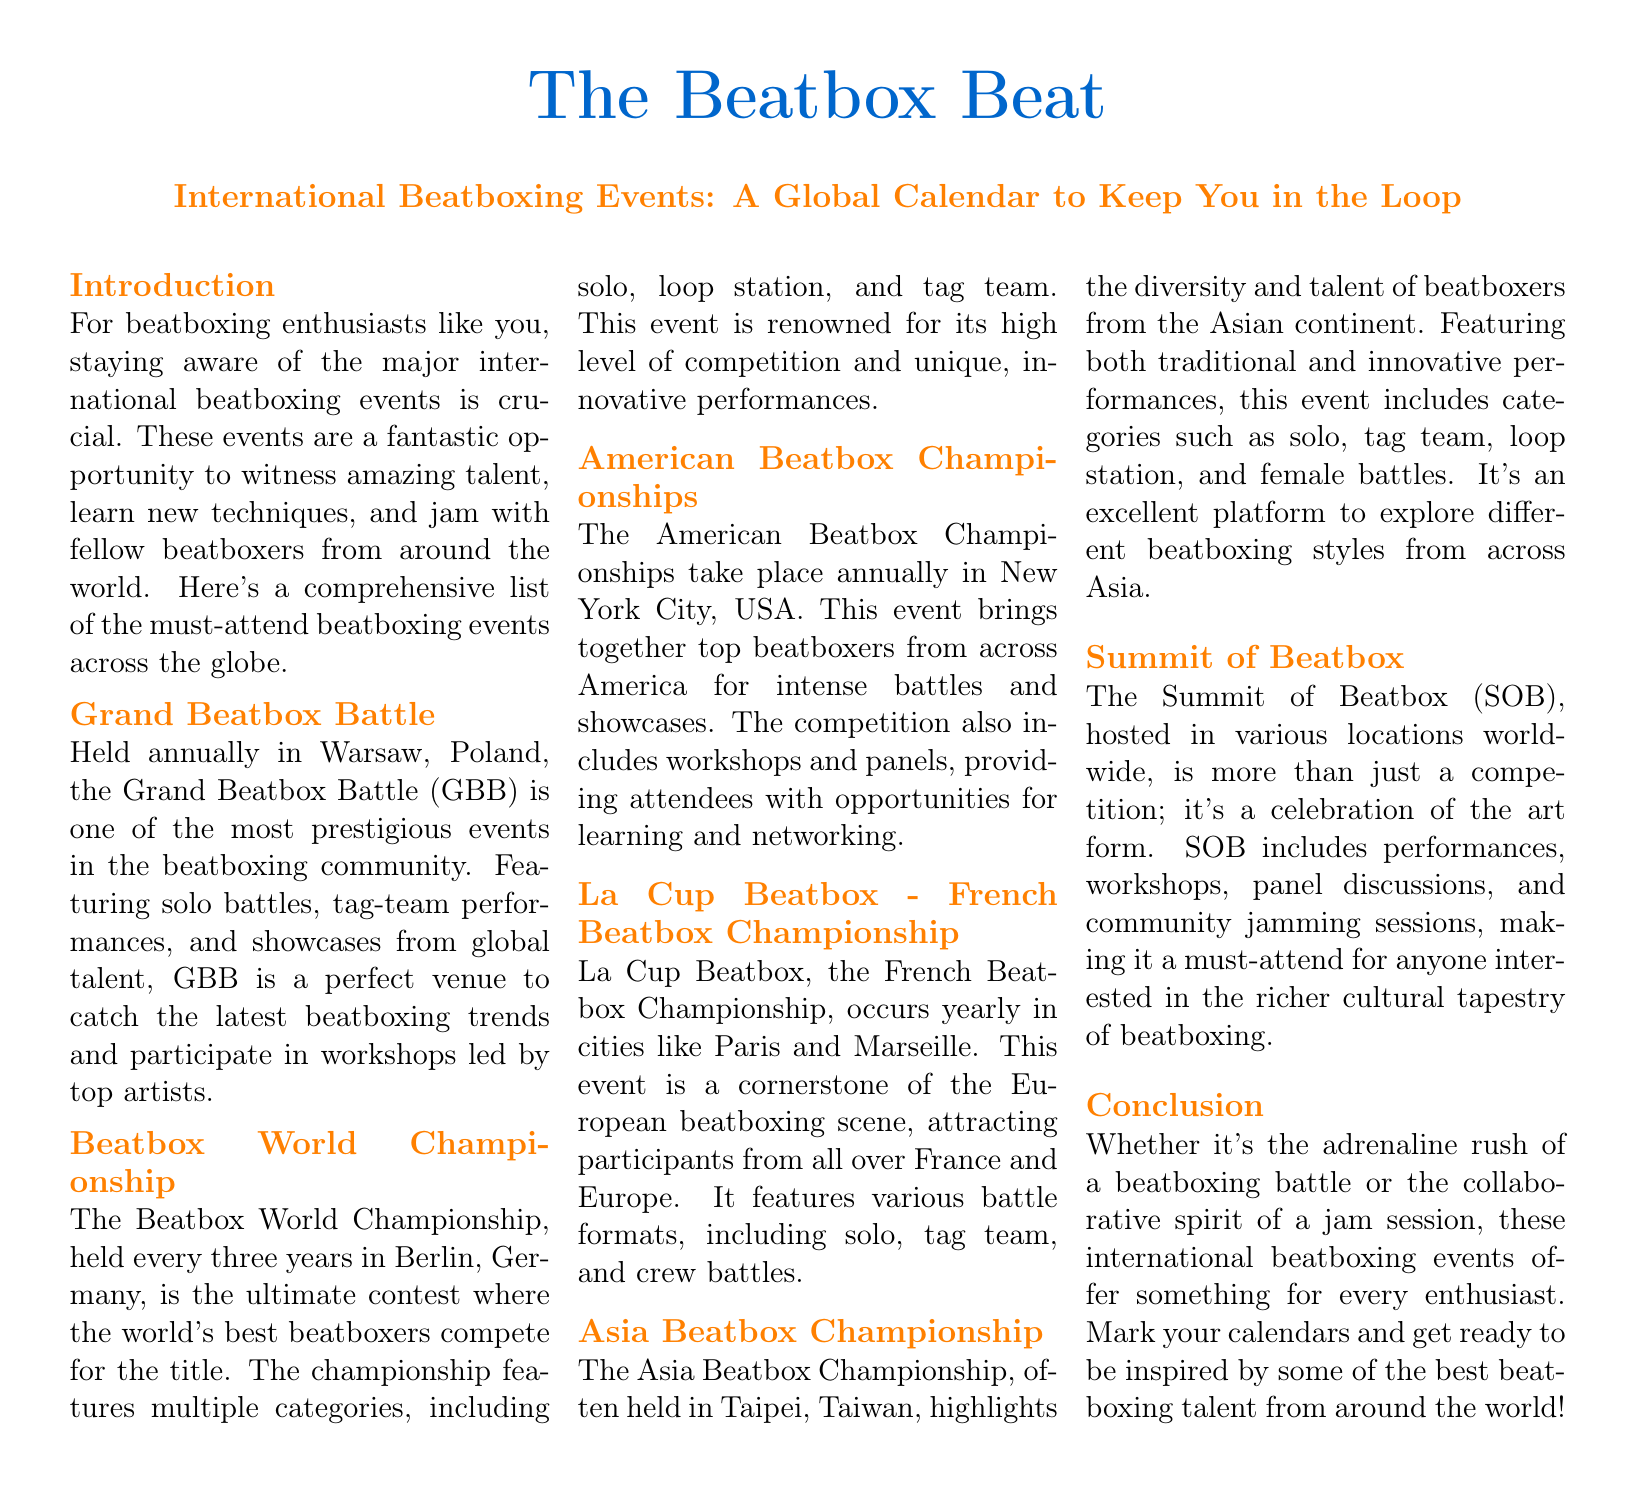What is the title of the document? The title of the document is prominently displayed at the top and is "The Beatbox Beat."
Answer: The Beatbox Beat Where is the Grand Beatbox Battle held? The document states that the Grand Beatbox Battle is held annually in Warsaw, Poland.
Answer: Warsaw, Poland How often is the Beatbox World Championship held? The document mentions that the Beatbox World Championship occurs every three years.
Answer: Every three years What city hosts the American Beatbox Championships? According to the document, the American Beatbox Championships take place in New York City, USA.
Answer: New York City, USA Which championship is known for highlighting diversity in Asia? The Asia Beatbox Championship is specifically mentioned as highlighting the diversity of beatboxers from the Asian continent.
Answer: Asia Beatbox Championship What type of event is the Summit of Beatbox? The document describes the Summit of Beatbox as more than just a competition; it's a celebration of the art form.
Answer: Celebration What is a typical feature of La Cup Beatbox? The document highlights that La Cup Beatbox features various battle formats, including solo, tag team, and crew battles.
Answer: Various battle formats How many categories are there at the Beatbox World Championship? The document lists multiple categories for the Beatbox World Championship, such as solo, loop station, and tag team, implying there are three main categories.
Answer: Three categories What is mentioned as a reason to attend international beatboxing events? The document states that these events offer opportunities to witness talent, learn new techniques, and jam with fellow beatboxers.
Answer: Opportunities to witness talent 